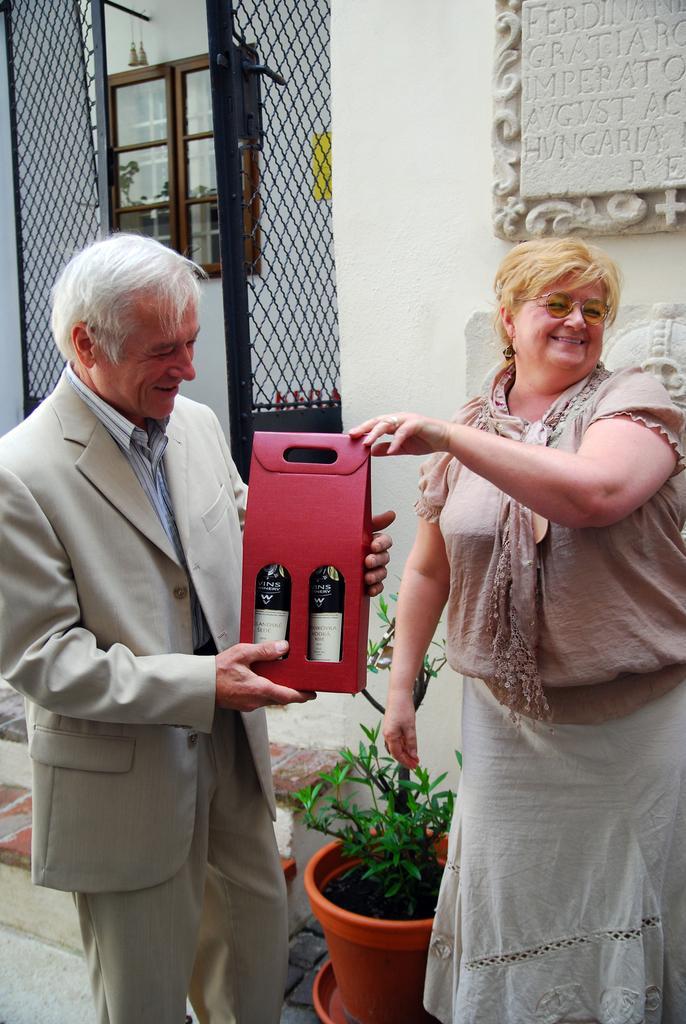Describe this image in one or two sentences. Here a woman is giving box to a man. Behind them there is a flower pot. plant,gate,cupboards and a wall. 